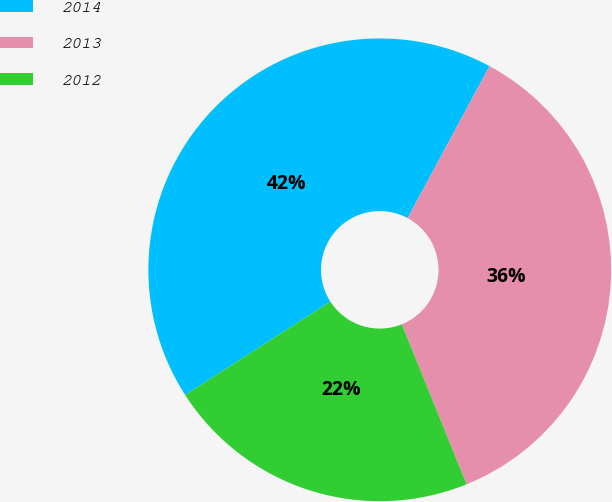Convert chart to OTSL. <chart><loc_0><loc_0><loc_500><loc_500><pie_chart><fcel>2014<fcel>2013<fcel>2012<nl><fcel>41.96%<fcel>36.01%<fcel>22.02%<nl></chart> 